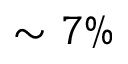Convert formula to latex. <formula><loc_0><loc_0><loc_500><loc_500>\sim 7 \%</formula> 